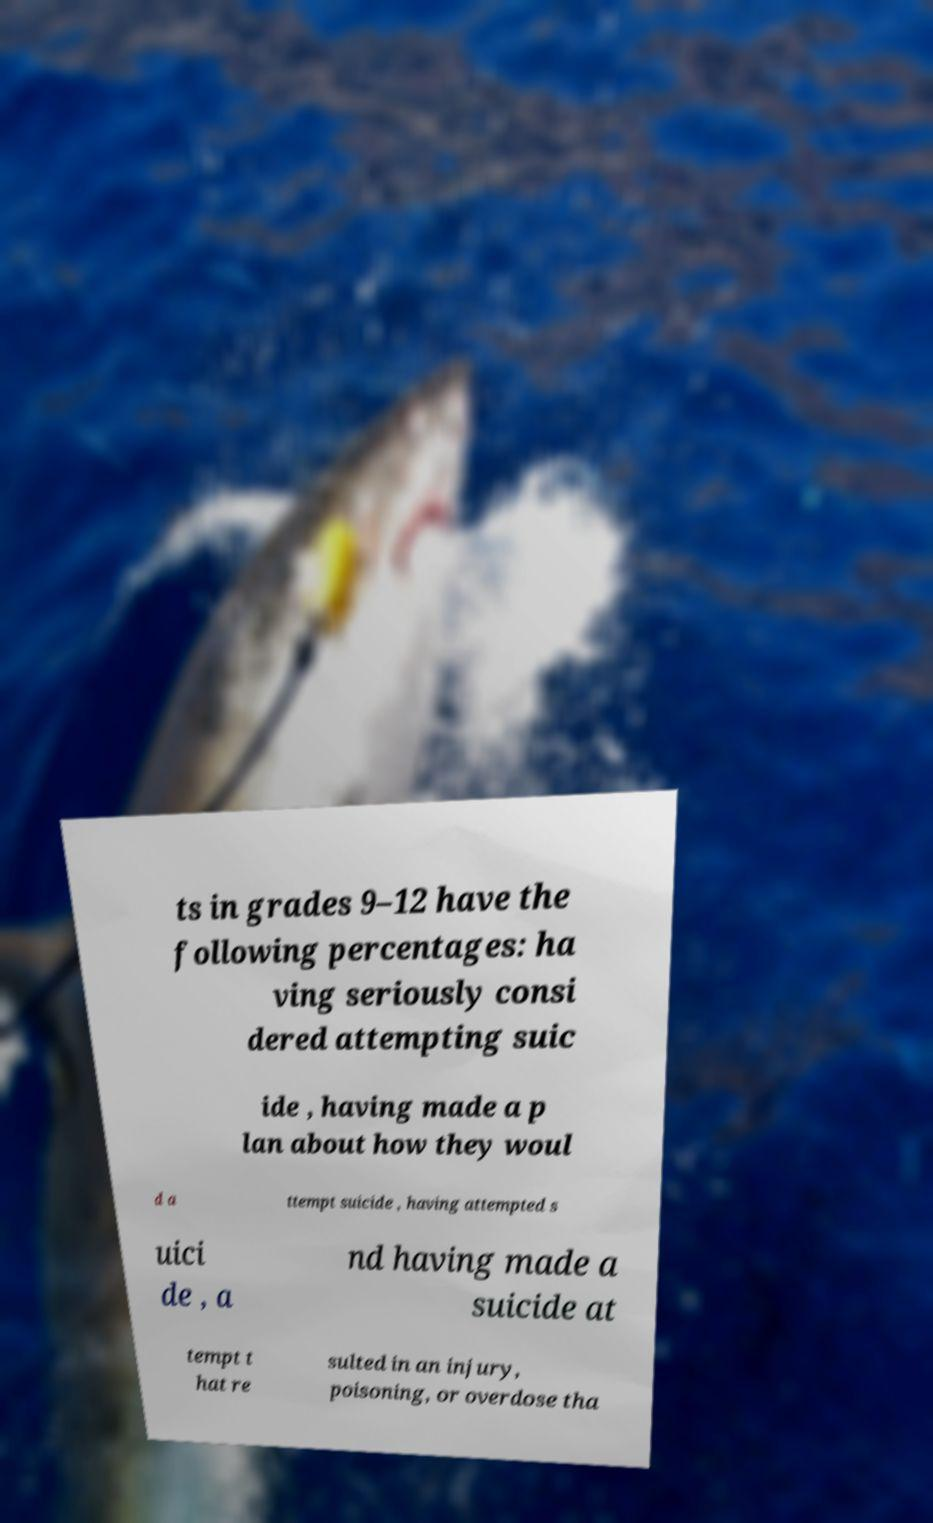Can you accurately transcribe the text from the provided image for me? ts in grades 9–12 have the following percentages: ha ving seriously consi dered attempting suic ide , having made a p lan about how they woul d a ttempt suicide , having attempted s uici de , a nd having made a suicide at tempt t hat re sulted in an injury, poisoning, or overdose tha 